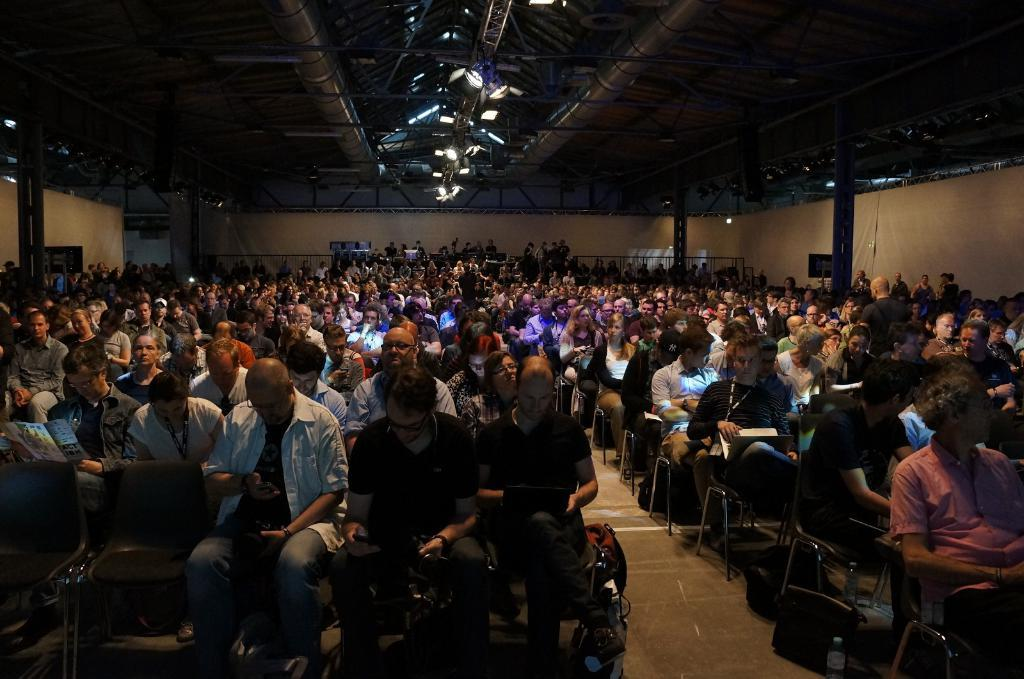What is happening in the image? There is a group of people in the image. How are the people positioned in the image? The people are sitting on chairs. What can be seen on the roof in the image? There are focused lights on the roof. How many cacti are present in the image? There are no cacti present in the image. What is the value of the dime on the chair? There is no dime present in the image. 